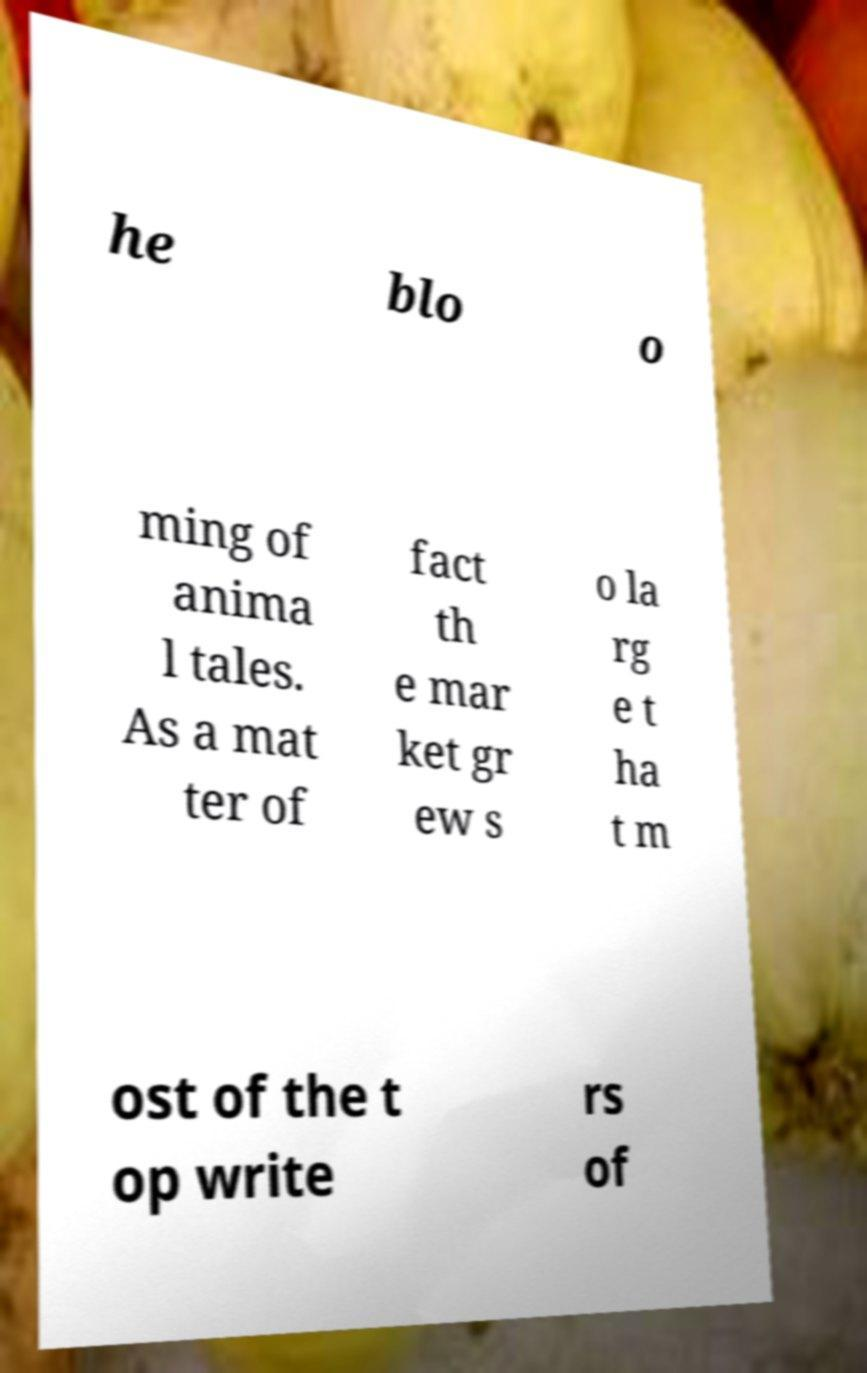Could you assist in decoding the text presented in this image and type it out clearly? he blo o ming of anima l tales. As a mat ter of fact th e mar ket gr ew s o la rg e t ha t m ost of the t op write rs of 